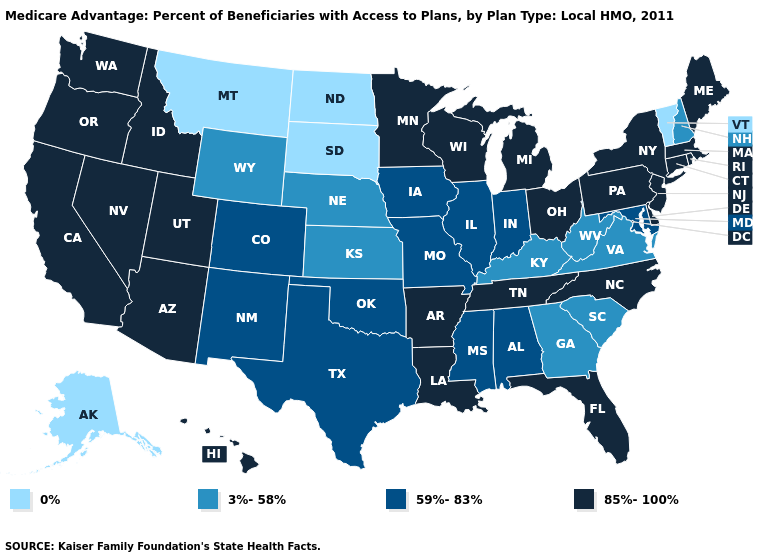What is the lowest value in the West?
Give a very brief answer. 0%. Name the states that have a value in the range 0%?
Short answer required. Alaska, Montana, North Dakota, South Dakota, Vermont. Which states have the highest value in the USA?
Quick response, please. Arkansas, Arizona, California, Connecticut, Delaware, Florida, Hawaii, Idaho, Louisiana, Massachusetts, Maine, Michigan, Minnesota, North Carolina, New Jersey, Nevada, New York, Ohio, Oregon, Pennsylvania, Rhode Island, Tennessee, Utah, Washington, Wisconsin. Name the states that have a value in the range 0%?
Give a very brief answer. Alaska, Montana, North Dakota, South Dakota, Vermont. Is the legend a continuous bar?
Be succinct. No. Name the states that have a value in the range 85%-100%?
Be succinct. Arkansas, Arizona, California, Connecticut, Delaware, Florida, Hawaii, Idaho, Louisiana, Massachusetts, Maine, Michigan, Minnesota, North Carolina, New Jersey, Nevada, New York, Ohio, Oregon, Pennsylvania, Rhode Island, Tennessee, Utah, Washington, Wisconsin. How many symbols are there in the legend?
Quick response, please. 4. Does the first symbol in the legend represent the smallest category?
Be succinct. Yes. What is the value of Rhode Island?
Concise answer only. 85%-100%. Name the states that have a value in the range 0%?
Be succinct. Alaska, Montana, North Dakota, South Dakota, Vermont. Name the states that have a value in the range 3%-58%?
Concise answer only. Georgia, Kansas, Kentucky, Nebraska, New Hampshire, South Carolina, Virginia, West Virginia, Wyoming. Name the states that have a value in the range 85%-100%?
Short answer required. Arkansas, Arizona, California, Connecticut, Delaware, Florida, Hawaii, Idaho, Louisiana, Massachusetts, Maine, Michigan, Minnesota, North Carolina, New Jersey, Nevada, New York, Ohio, Oregon, Pennsylvania, Rhode Island, Tennessee, Utah, Washington, Wisconsin. What is the highest value in the USA?
Quick response, please. 85%-100%. How many symbols are there in the legend?
Quick response, please. 4. Name the states that have a value in the range 85%-100%?
Keep it brief. Arkansas, Arizona, California, Connecticut, Delaware, Florida, Hawaii, Idaho, Louisiana, Massachusetts, Maine, Michigan, Minnesota, North Carolina, New Jersey, Nevada, New York, Ohio, Oregon, Pennsylvania, Rhode Island, Tennessee, Utah, Washington, Wisconsin. 